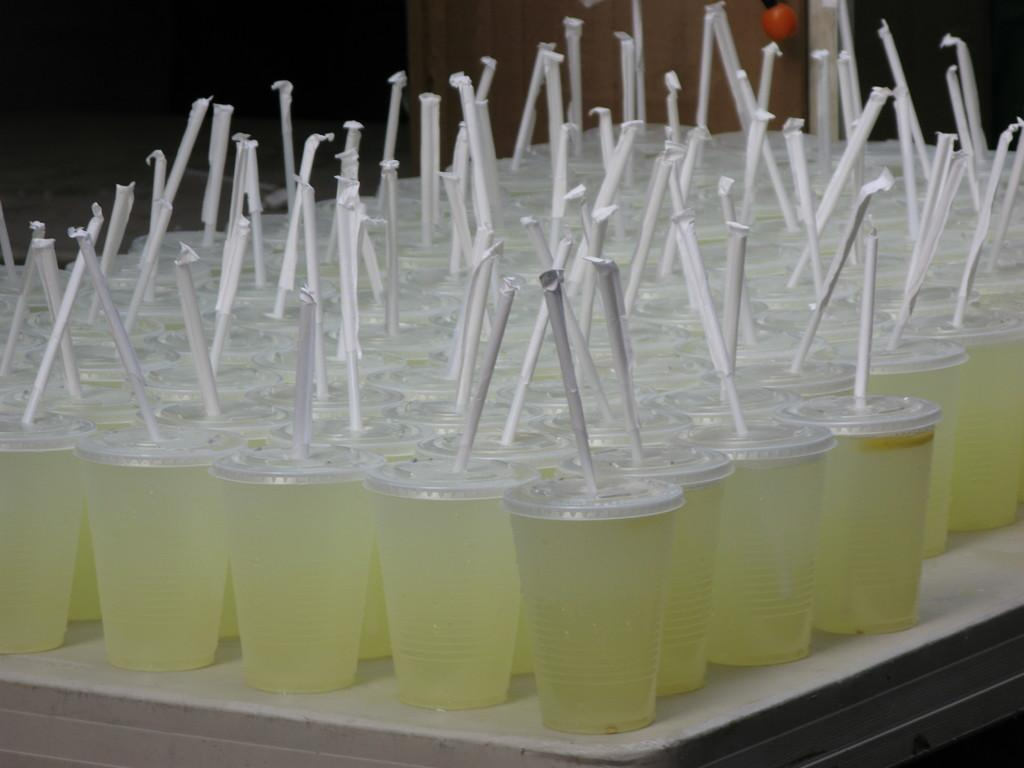What type of containers are visible in the image? There are drink glasses in the image. What feature do the drink glasses have? The drink glasses have straws. Where are the drink glasses placed? The drink glasses are on an object. What type of chin can be seen on the drink glasses in the image? There is no chin present on the drink glasses in the image; they are inanimate objects. 